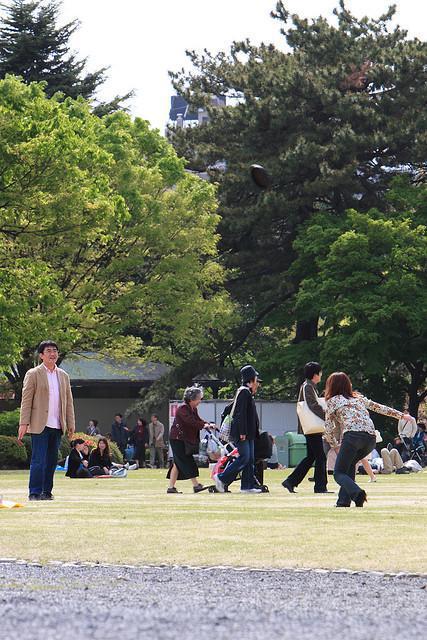How many people are in the picture?
Give a very brief answer. 5. 